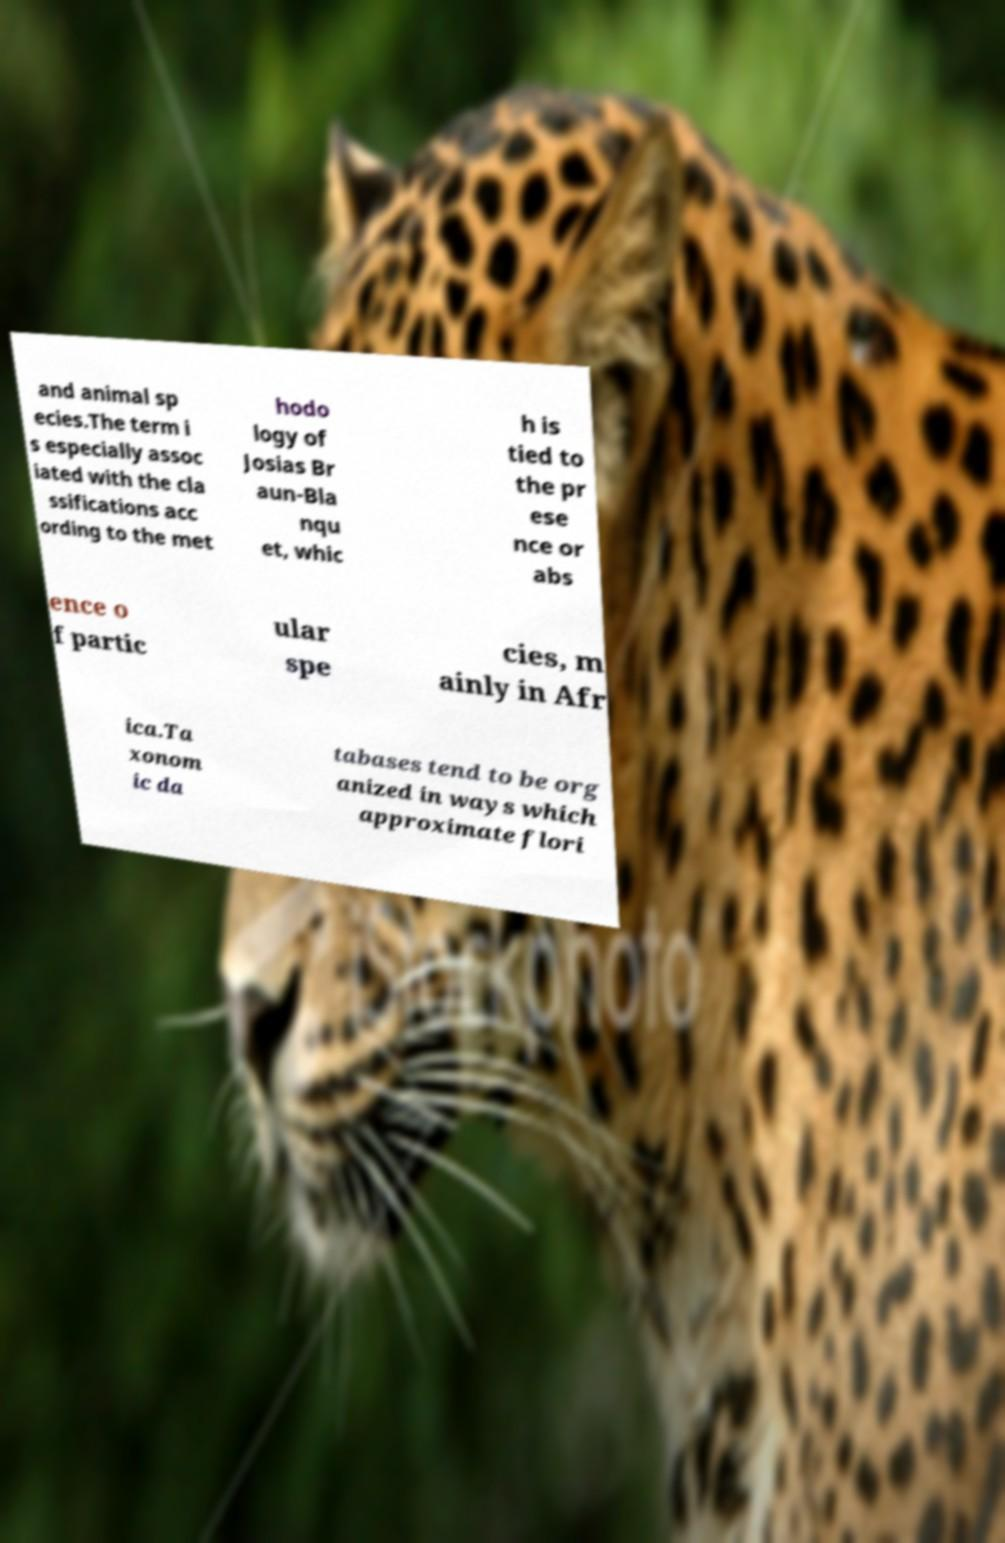Can you accurately transcribe the text from the provided image for me? and animal sp ecies.The term i s especially assoc iated with the cla ssifications acc ording to the met hodo logy of Josias Br aun-Bla nqu et, whic h is tied to the pr ese nce or abs ence o f partic ular spe cies, m ainly in Afr ica.Ta xonom ic da tabases tend to be org anized in ways which approximate flori 